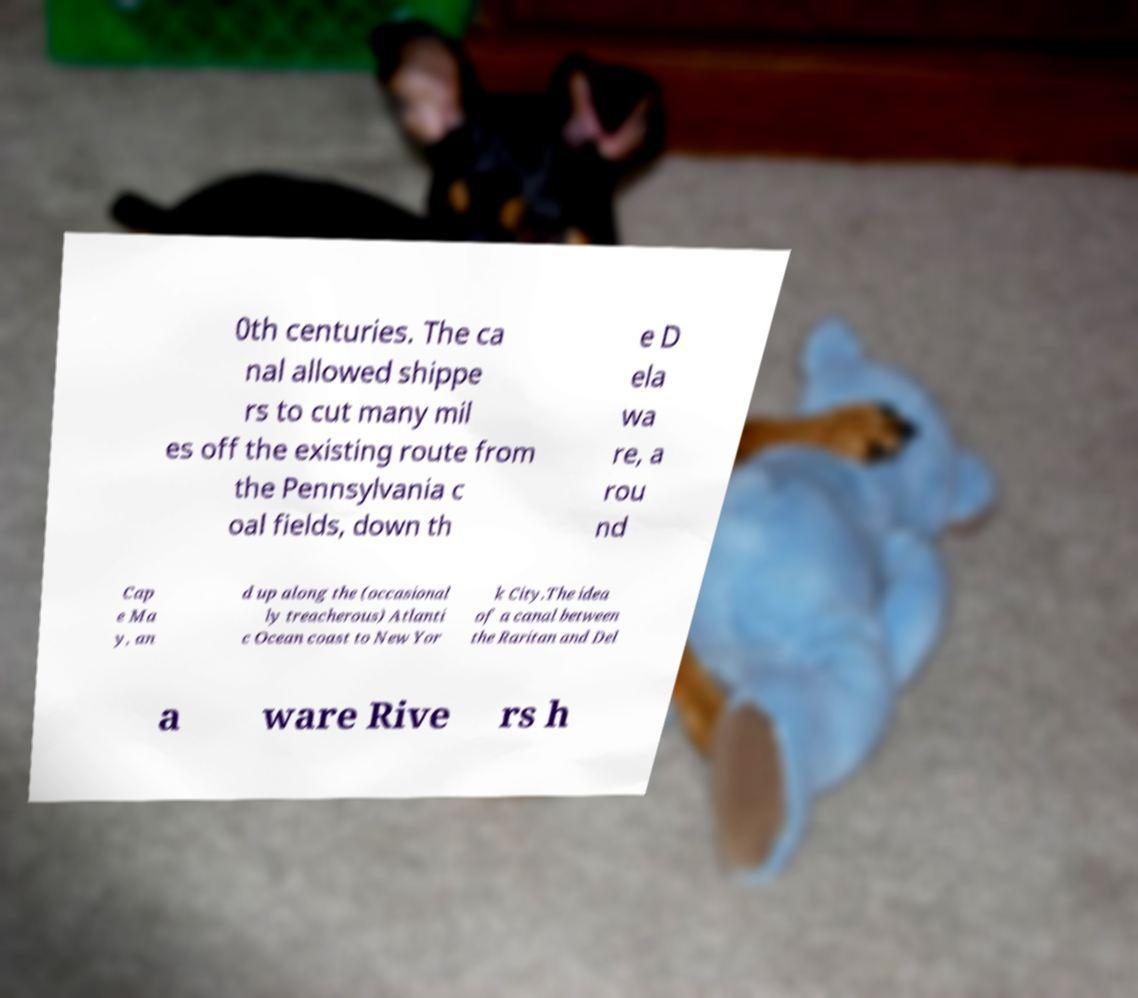For documentation purposes, I need the text within this image transcribed. Could you provide that? 0th centuries. The ca nal allowed shippe rs to cut many mil es off the existing route from the Pennsylvania c oal fields, down th e D ela wa re, a rou nd Cap e Ma y, an d up along the (occasional ly treacherous) Atlanti c Ocean coast to New Yor k City.The idea of a canal between the Raritan and Del a ware Rive rs h 